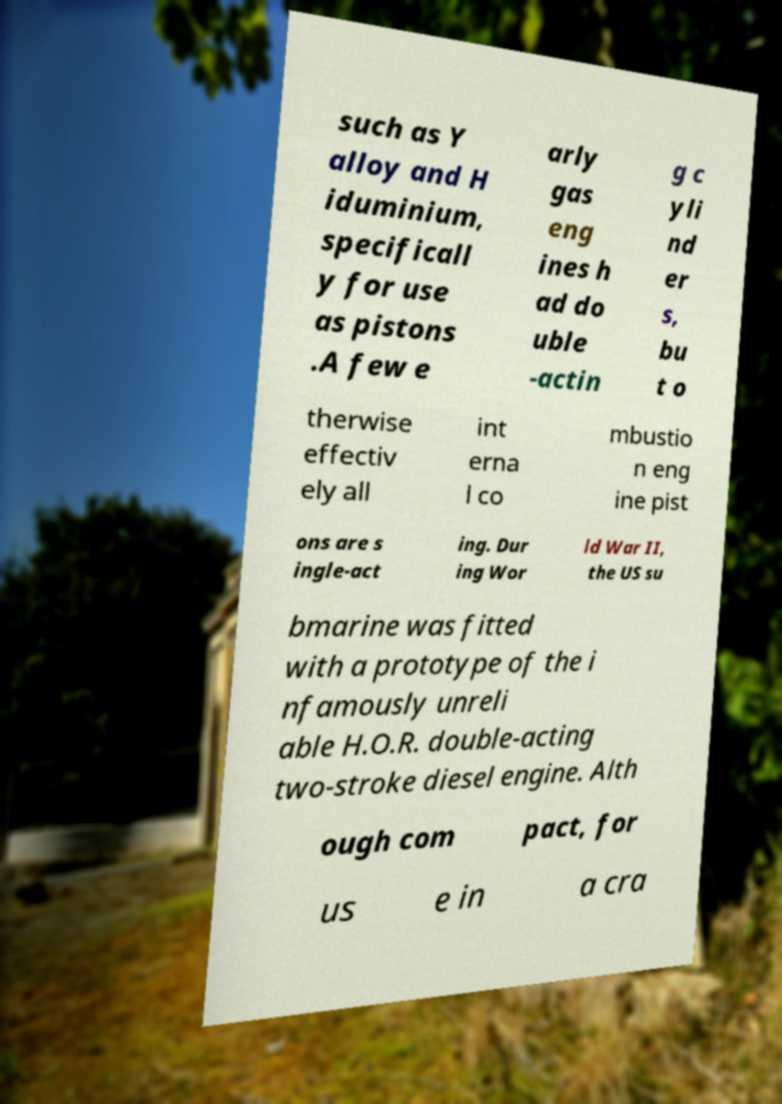Can you read and provide the text displayed in the image?This photo seems to have some interesting text. Can you extract and type it out for me? such as Y alloy and H iduminium, specificall y for use as pistons .A few e arly gas eng ines h ad do uble -actin g c yli nd er s, bu t o therwise effectiv ely all int erna l co mbustio n eng ine pist ons are s ingle-act ing. Dur ing Wor ld War II, the US su bmarine was fitted with a prototype of the i nfamously unreli able H.O.R. double-acting two-stroke diesel engine. Alth ough com pact, for us e in a cra 